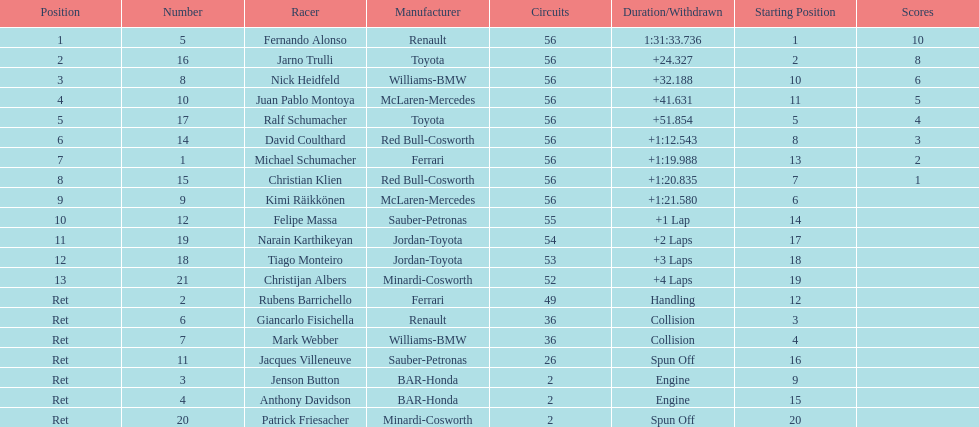Jarno trulli was not french but what nationality? Italian. 